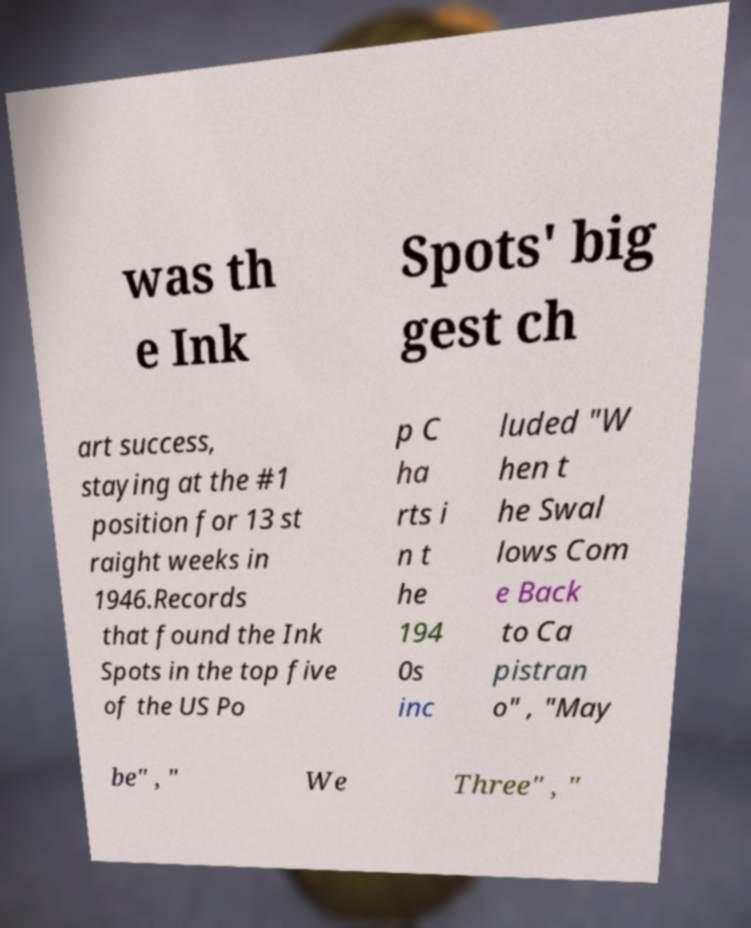Please identify and transcribe the text found in this image. was th e Ink Spots' big gest ch art success, staying at the #1 position for 13 st raight weeks in 1946.Records that found the Ink Spots in the top five of the US Po p C ha rts i n t he 194 0s inc luded "W hen t he Swal lows Com e Back to Ca pistran o" , "May be" , " We Three" , " 